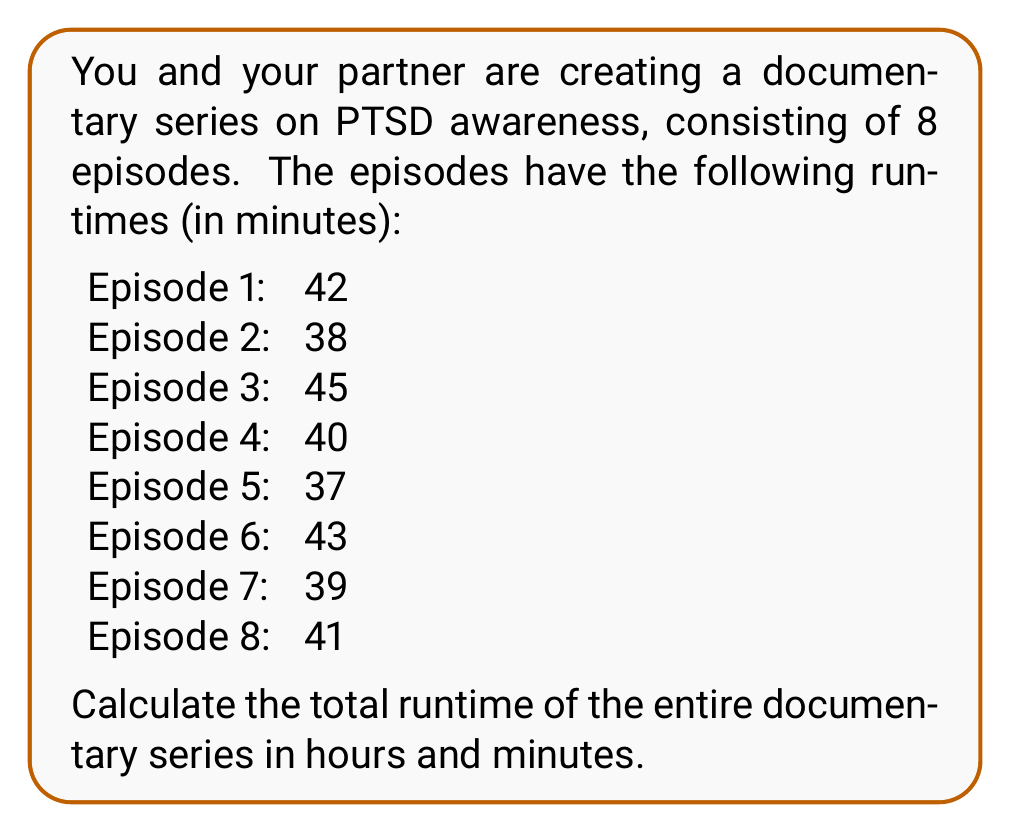Give your solution to this math problem. To solve this problem, we'll follow these steps:

1. Calculate the total runtime in minutes:
   $$\text{Total minutes} = 42 + 38 + 45 + 40 + 37 + 43 + 39 + 41 = 325 \text{ minutes}$$

2. Convert the total minutes to hours and minutes:
   - There are 60 minutes in an hour, so we divide the total minutes by 60:
     $$325 \div 60 = 5 \text{ remainder } 25$$
   
   - This means there are 5 complete hours and 25 remaining minutes.

Therefore, the total runtime of the documentary series is 5 hours and 25 minutes.
Answer: 5 hours and 25 minutes 